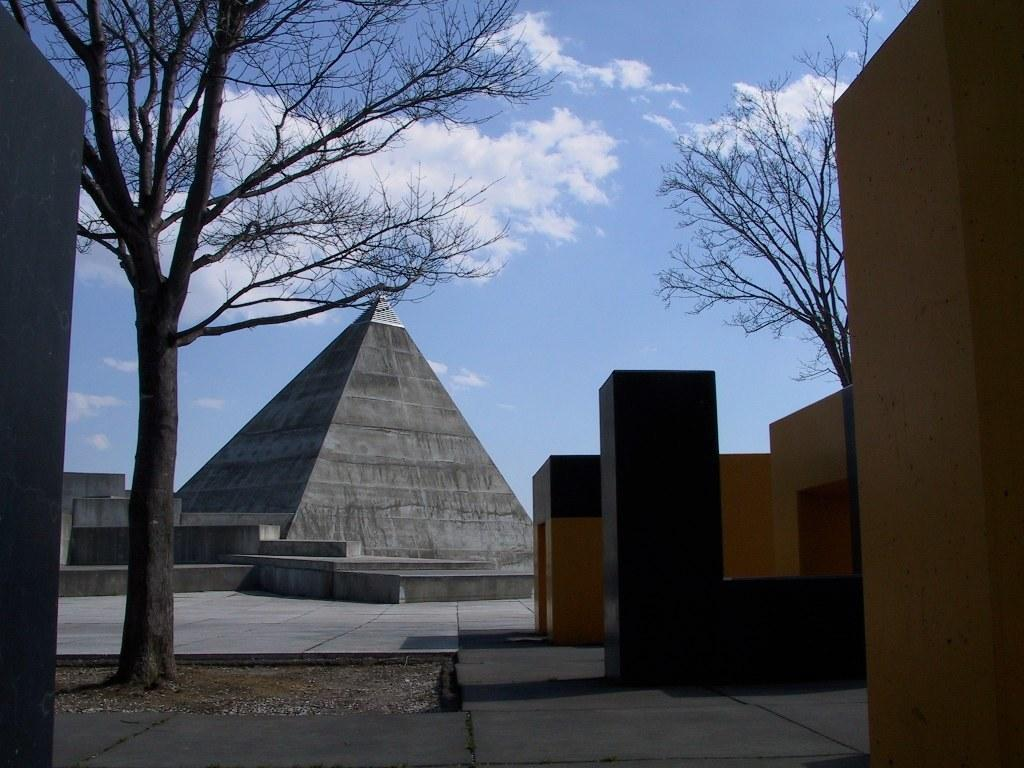What structure can be seen in the image that resembles a pyramid? There is an object in the image that resembles a pyramid. What type of natural element is present in the image? There is a tree in the image. What is the opinion of the jail in the image? There is no jail present in the image, so it is not possible to determine its opinion. 